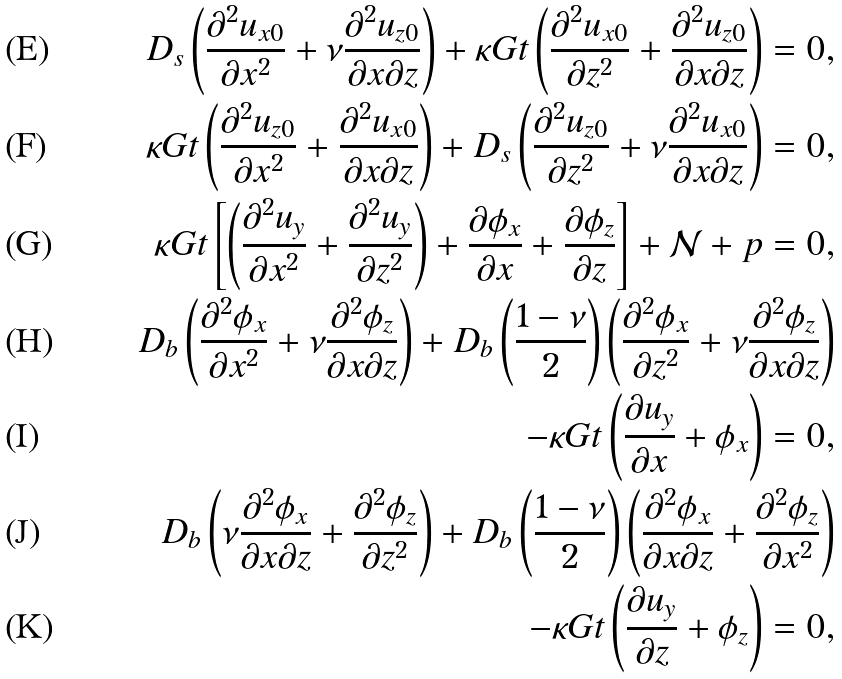Convert formula to latex. <formula><loc_0><loc_0><loc_500><loc_500>D _ { s } \left ( \frac { \partial ^ { 2 } u _ { x 0 } } { \partial x ^ { 2 } } + \nu \frac { \partial ^ { 2 } u _ { z 0 } } { \partial x \partial z } \right ) + \kappa G t \left ( \frac { \partial ^ { 2 } u _ { x 0 } } { \partial z ^ { 2 } } + \frac { \partial ^ { 2 } u _ { z 0 } } { \partial x \partial z } \right ) = 0 , \\ \kappa G t \left ( \frac { \partial ^ { 2 } u _ { z 0 } } { \partial x ^ { 2 } } + \frac { \partial ^ { 2 } u _ { x 0 } } { \partial x \partial z } \right ) + D _ { s } \left ( \frac { \partial ^ { 2 } u _ { z 0 } } { \partial z ^ { 2 } } + \nu \frac { \partial ^ { 2 } u _ { x 0 } } { \partial x \partial z } \right ) = 0 , \\ \kappa G t \left [ \left ( \frac { \partial ^ { 2 } u _ { y } } { \partial x ^ { 2 } } + \frac { \partial ^ { 2 } u _ { y } } { \partial z ^ { 2 } } \right ) + \frac { \partial \phi _ { x } } { \partial x } + \frac { \partial \phi _ { z } } { \partial z } \right ] + \mathcal { N } + p = 0 , \\ D _ { b } \left ( \frac { \partial ^ { 2 } \phi _ { x } } { \partial x ^ { 2 } } + \nu \frac { \partial ^ { 2 } \phi _ { z } } { \partial x \partial z } \right ) + D _ { b } \left ( \frac { 1 - \nu } { 2 } \right ) \left ( \frac { \partial ^ { 2 } \phi _ { x } } { \partial z ^ { 2 } } + \nu \frac { \partial ^ { 2 } \phi _ { z } } { \partial x \partial z } \right ) \\ - { \kappa G t } \left ( \frac { \partial u _ { y } } { \partial x } + \phi _ { x } \right ) = 0 , \\ D _ { b } \left ( \nu \frac { \partial ^ { 2 } \phi _ { x } } { \partial x \partial z } + \frac { \partial ^ { 2 } \phi _ { z } } { \partial z ^ { 2 } } \right ) + D _ { b } \left ( \frac { 1 - \nu } { 2 } \right ) \left ( \frac { \partial ^ { 2 } \phi _ { x } } { \partial x \partial z } + \frac { \partial ^ { 2 } \phi _ { z } } { \partial x ^ { 2 } } \right ) \\ - \kappa G t \left ( \frac { \partial u _ { y } } { \partial z } + \phi _ { z } \right ) = 0 ,</formula> 